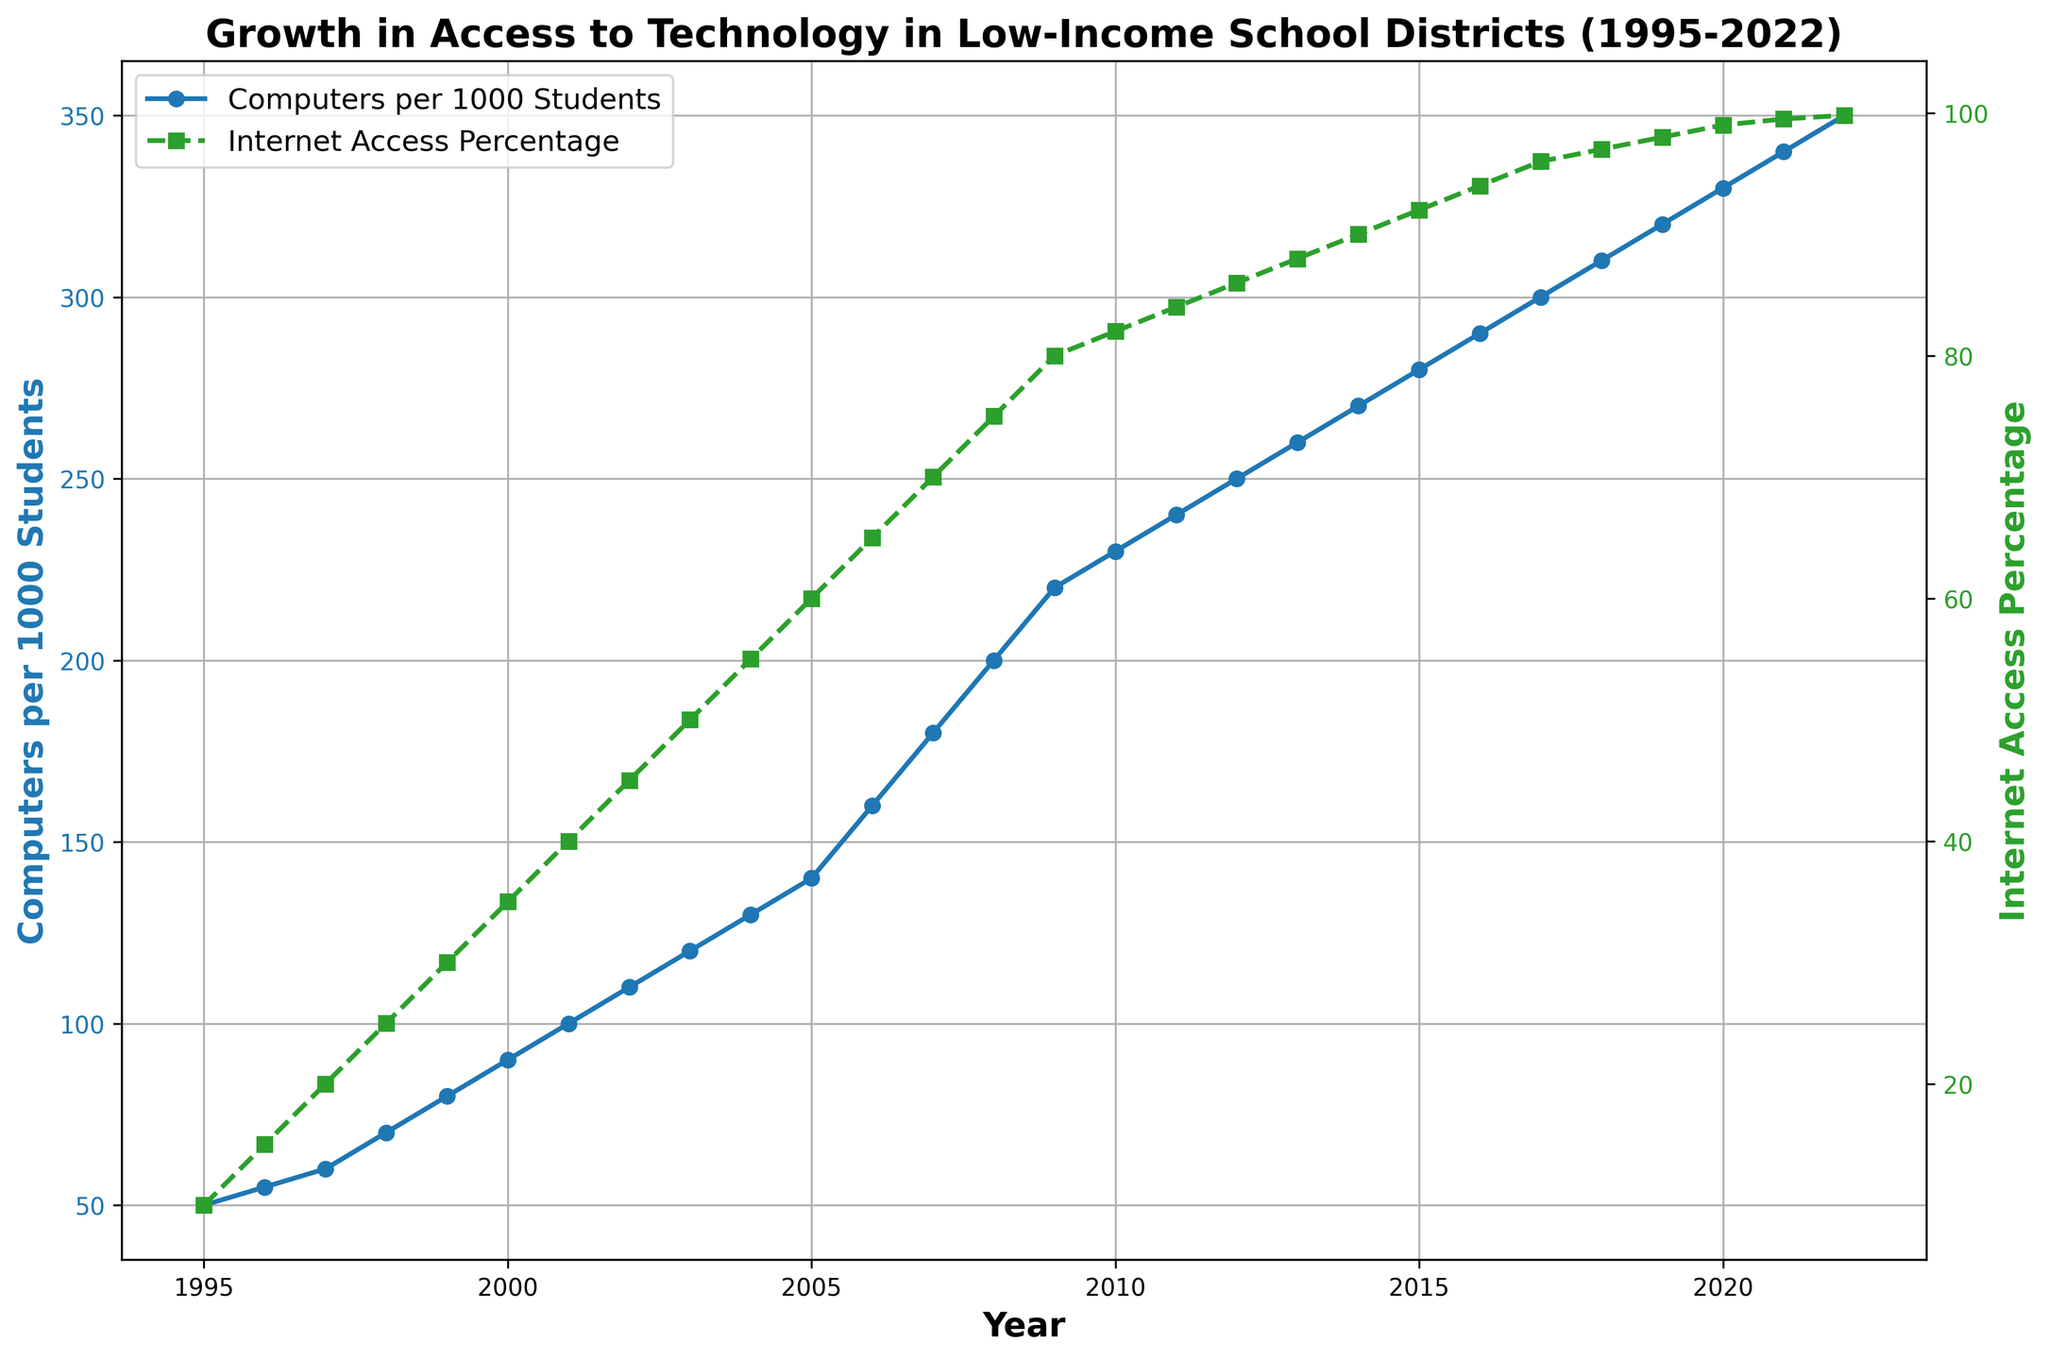What was the number of computers per 1000 students in 1995? Look at the plot's y-axis corresponding to 'Computers per 1000 Students' for the year 1995. It shows approximately 50.
Answer: 50 By how much did the internet access percentage increase from 1995 to 2000? Subtract the internet access percentage in 1995 from the percentage in 2000: 35% - 10% = 25%.
Answer: 25% In which year did the number of computers per 1000 students first reach 200? Look at the 'Computers per 1000 Students' plot and identify the year where the value first reaches 200. It occurs in 2008.
Answer: 2008 Compare the growth rate of computers per 1000 students between 2005 and 2010 with the growth rate between 2015 and 2020. Which period had a higher growth rate? Calculate the rates by finding the difference for each period: 
2005 to 2010: 230 - 140 = 90 computers, 2015 to 2020: 330 - 280 = 50 computers. The period 2005 to 2010 had a higher growth rate.
Answer: 2005 to 2010 What is the relationship between the trends in "Computers per 1000 Students" and "Internet Access Percentage" over the years? Both trends increase steadily over the years, with the number of computers and internet access percentage both showing growth, though internet access reaches a plateau close to 100%.
Answer: Both increase By how much did the computers per 1000 students increase from 1995 to 2022? Subtract the 1995 value from the 2022 value: 350 - 50 = 300 computers per 1000 students.
Answer: 300 Which metric had a more significant absolute change from 2000 to 2010, and by how much? Calculate the changes for each metric:
Computers: 230 - 90 = 140, Internet Access: 82% - 35% = 47%. The computers per 1000 students had a higher absolute change of 140.
Answer: Computers, 140 Which year shows the highest rate of increase in Internet Access Percentage? Observing the steepness of the curve for internet access, the year 1998 shows a sharp inclination, which indicates a high rate of increase.
Answer: 1998 What percentage of low-income school districts had internet access in 2015, and how does it compare to 2010? Look at the plotted points for both years: 2015 shows 92%, and 2010 shows 82%. 92% - 82% = 10% increase.
Answer: 92%, increased by 10% In what year did the internet access percentage plateau close to 100%? The internet access percentage curve flattens around the 99% mark starting from the year 2019.
Answer: 2019 